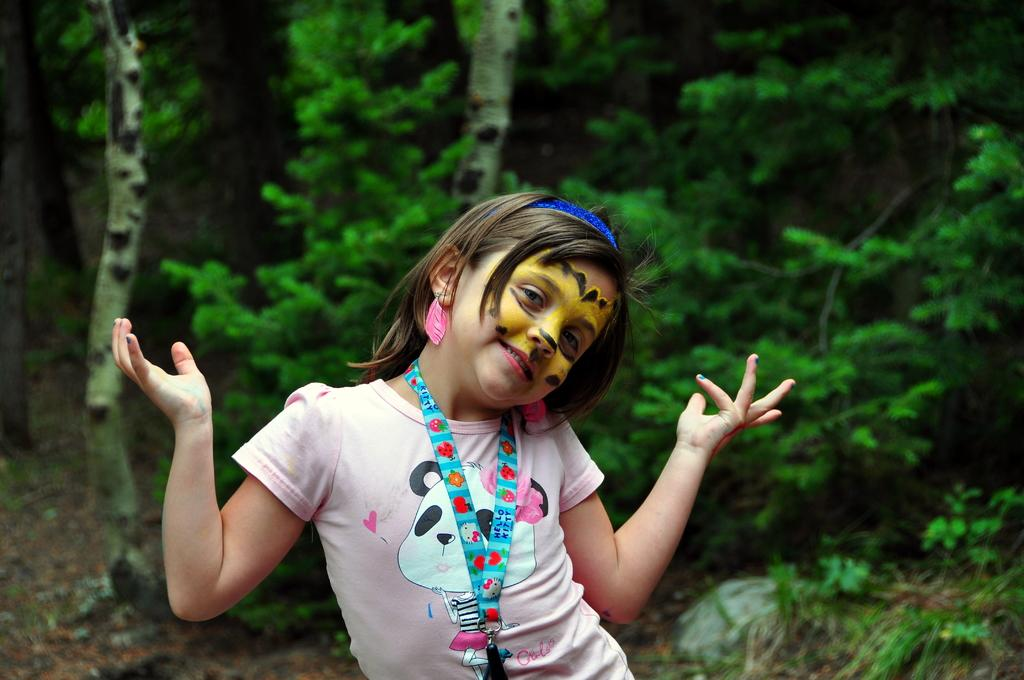What is the main subject of the image? There is a person in the image. What is the person wearing in the image? The person is wearing a pink shirt. What can be seen in the background of the image? There are trees in the background of the image. What is the color of the trees in the image? The trees are green in color. Can you see a match being lit in the image? There is no match or any indication of a fire in the image. What type of book is the person holding in the image? There is no book present in the image. 